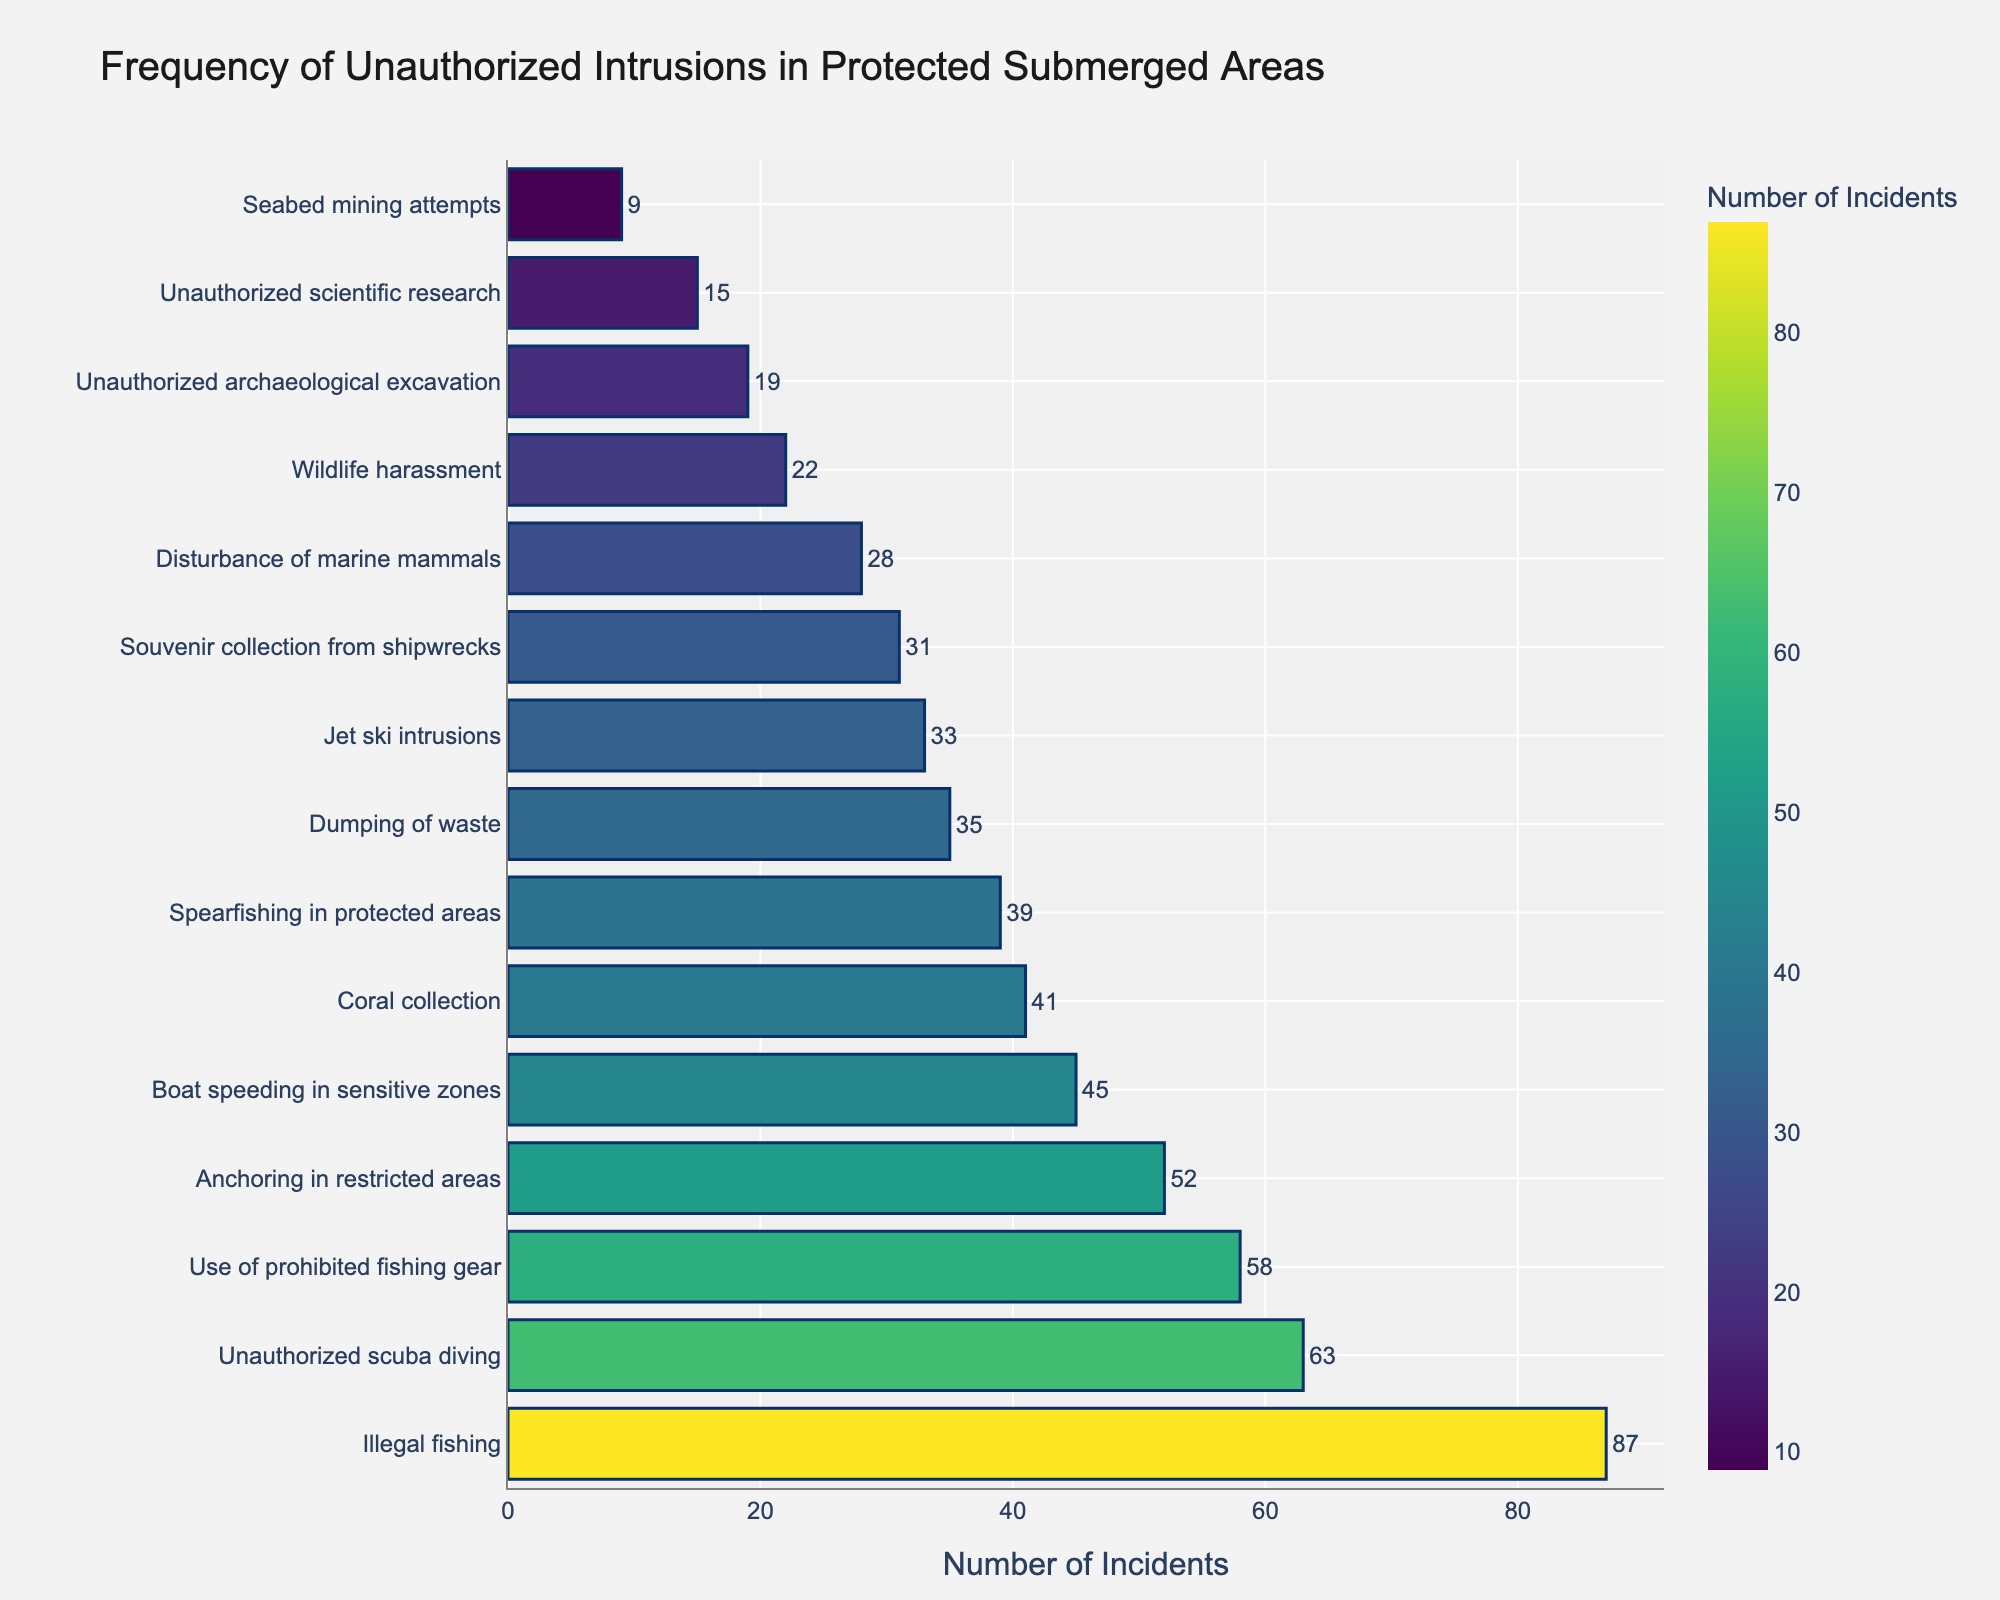What type of violation has the highest frequency? The bar at the top represents the violation with the highest frequency. From the sorted data, "Illegal fishing" appears at the top of the chart.
Answer: Illegal fishing What is the combined frequency of unauthorized scuba diving, coral collection, and boat speeding in sensitive zones? The frequencies are 63, 41, and 45 respectively. Adding them together, 63 + 41 + 45 = 149.
Answer: 149 Which has a higher frequency: the use of prohibited fishing gear or spearfishing in protected areas? Locate the bars for both violations in the chart. "Use of prohibited fishing gear" has a frequency of 58, and "Spearfishing in protected areas" has a frequency of 39. Since 58 > 39, the former has a higher frequency.
Answer: Use of prohibited fishing gear What is the difference in frequency between jet ski intrusions and souvenir collection from shipwrecks? The frequency for jet ski intrusions is 33, and for souvenir collection from shipwrecks, it is 31. The difference is 33 - 31 = 2.
Answer: 2 What is the frequency of the least common violation, and which violation is it? The shortest bar represents the least common violation. "Seabed mining attempts" is the smallest with a frequency of 9.
Answer: 9, Seabed mining attempts Is the frequency of wildlife harassment higher than the frequency of unauthorized archaeological excavation? The frequencies are 22 and 19 respectively. Since 22 > 19, wildlife harassment is higher.
Answer: Yes What is the sum of frequencies for violations related to fishing (illegal fishing, use of prohibited fishing gear, spearfishing in protected areas)? The frequencies are 87 (illegal fishing), 58 (use of prohibited fishing gear), and 39 (spearfishing). Adding them, 87 + 58 + 39 = 184.
Answer: 184 How does the frequency of dumping of waste compare to anchoring in restricted areas? The frequencies are 35 for dumping of waste and 52 for anchoring in restricted areas. Since 35 < 52, dumping of waste has a lower frequency.
Answer: Dumping of waste has a lower frequency Which violation has a frequency between 60 and 70? By checking the bars and their frequencies, "Unauthorized scuba diving" has a frequency of 63, which falls within this range.
Answer: Unauthorized scuba diving What is the average frequency of all violations related to collecting (coral collection, souvenir collection from shipwrecks)? The frequencies are 41 (coral collection) and 31 (souvenir collection). The average is (41 + 31) / 2 = 36.
Answer: 36 